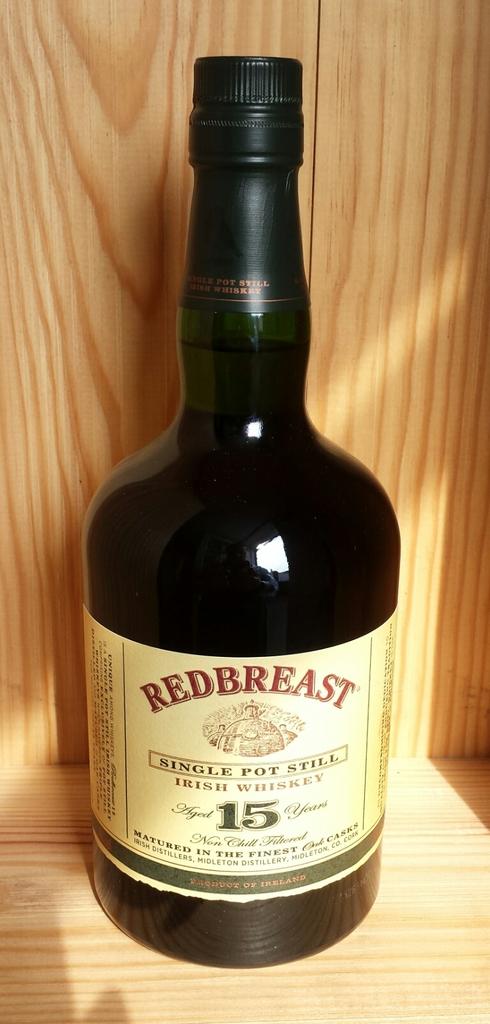What number is written on the bottle?
Your response must be concise. 15. 